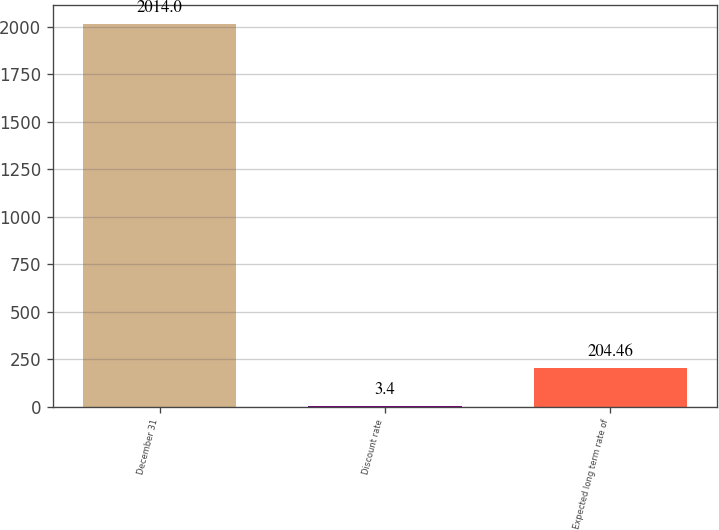Convert chart. <chart><loc_0><loc_0><loc_500><loc_500><bar_chart><fcel>December 31<fcel>Discount rate<fcel>Expected long term rate of<nl><fcel>2014<fcel>3.4<fcel>204.46<nl></chart> 